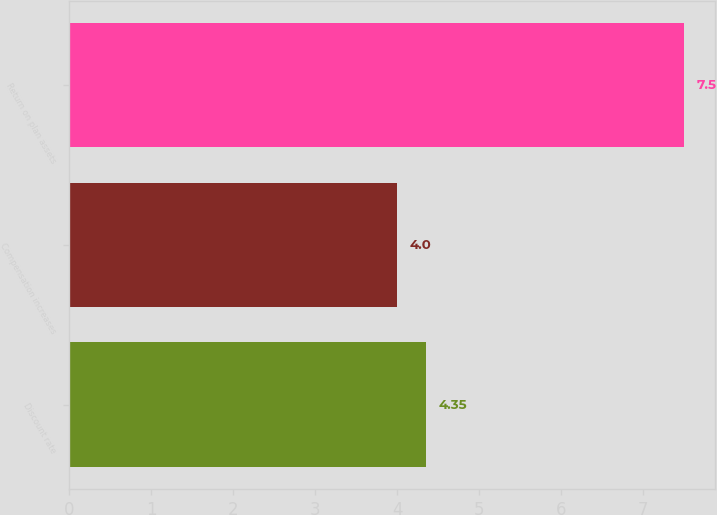Convert chart to OTSL. <chart><loc_0><loc_0><loc_500><loc_500><bar_chart><fcel>Discount rate<fcel>Compensation increases<fcel>Return on plan assets<nl><fcel>4.35<fcel>4<fcel>7.5<nl></chart> 